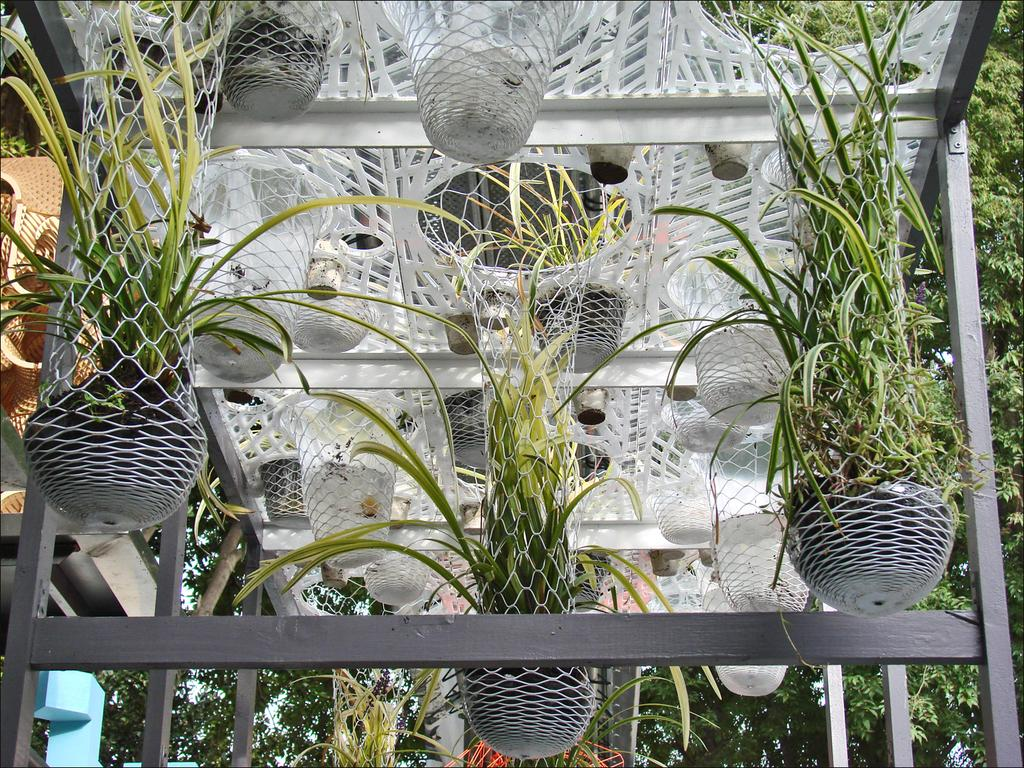What is located in the center of the image? There is a roof in the center of the image. What can be found in the image besides the roof? There are flower pots, a net, plants, and objects in the image. What type of vegetation is present in the image? There are plants and trees in the image. What can be seen in the background of the image? There are trees and objects in the background of the image. Who is the creator of the building in the image? There is no building present in the image, so it is not possible to determine the creator. How many apples are hanging from the trees in the image? There are no apples visible in the image; only trees and objects can be seen in the background. 